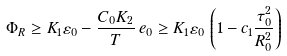Convert formula to latex. <formula><loc_0><loc_0><loc_500><loc_500>\Phi _ { R } \geq { K _ { 1 } } \varepsilon _ { 0 } - \frac { C _ { 0 } K _ { 2 } } { T } \, e _ { 0 } \geq K _ { 1 } \varepsilon _ { 0 } \, \left ( 1 - c _ { 1 } \frac { \tau _ { 0 } ^ { 2 } } { R _ { 0 } ^ { 2 } } \right )</formula> 